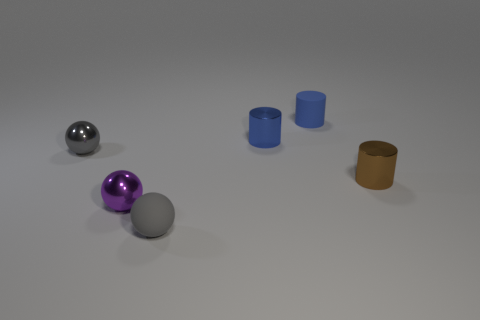Do the shiny cylinder that is left of the small brown metallic thing and the tiny rubber cylinder have the same color?
Give a very brief answer. Yes. There is a small thing that is the same color as the matte cylinder; what shape is it?
Your response must be concise. Cylinder. Do the metallic thing that is behind the tiny gray metal object and the matte object that is behind the small gray metal thing have the same color?
Your answer should be very brief. Yes. There is a tiny gray object that is in front of the small brown metal thing right of the blue matte thing; are there any brown cylinders that are behind it?
Your answer should be very brief. Yes. Do the cylinder that is in front of the blue shiny thing and the small purple object have the same material?
Keep it short and to the point. Yes. There is another small shiny thing that is the same shape as the brown thing; what is its color?
Your answer should be very brief. Blue. Are there an equal number of cylinders in front of the small brown metal thing and big red matte spheres?
Keep it short and to the point. Yes. Are there any small metal cylinders in front of the brown metallic cylinder?
Give a very brief answer. No. What size is the gray ball in front of the small metallic object in front of the brown cylinder that is behind the tiny purple ball?
Keep it short and to the point. Small. Is the shape of the tiny metallic object that is on the right side of the small blue metallic cylinder the same as the metallic thing behind the gray metallic sphere?
Your response must be concise. Yes. 